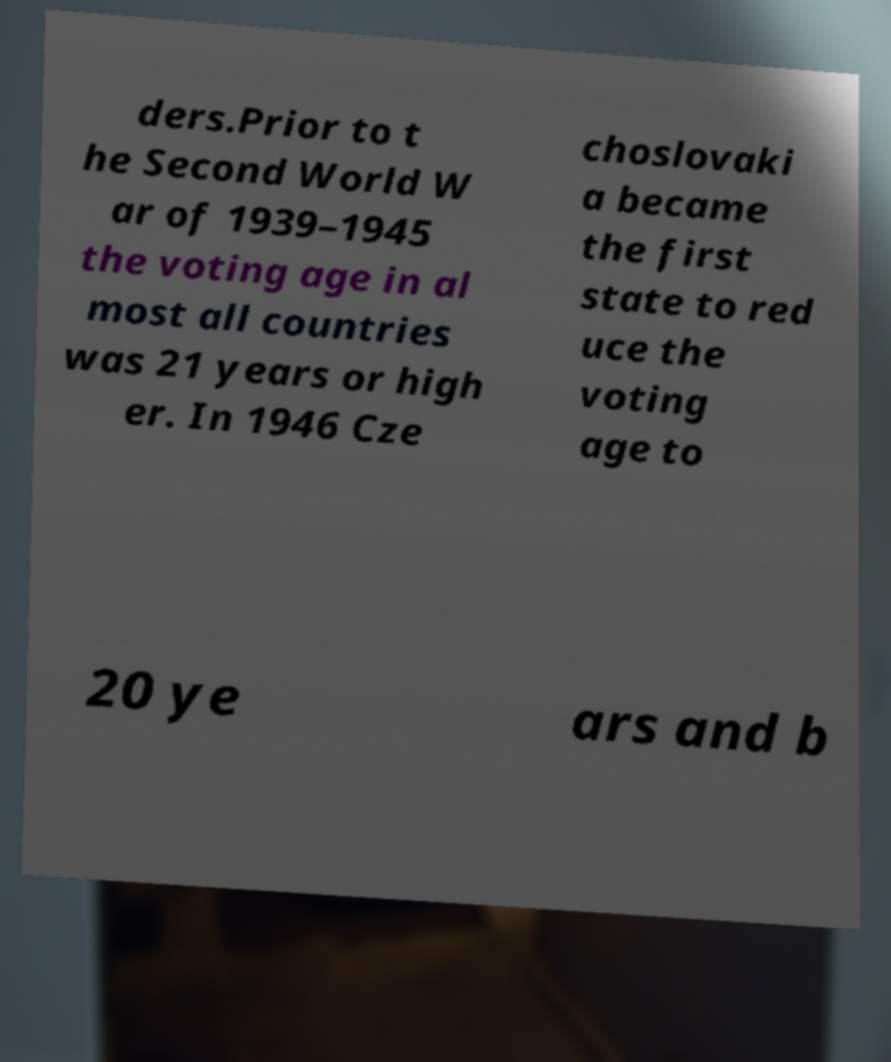Can you accurately transcribe the text from the provided image for me? ders.Prior to t he Second World W ar of 1939–1945 the voting age in al most all countries was 21 years or high er. In 1946 Cze choslovaki a became the first state to red uce the voting age to 20 ye ars and b 